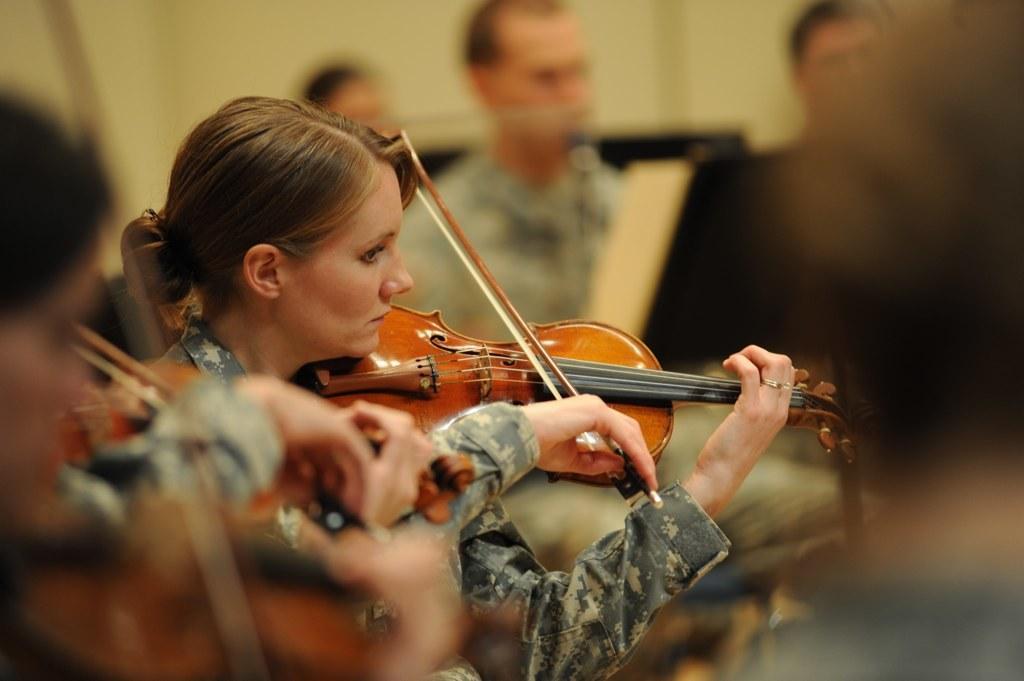Please provide a concise description of this image. This picture is blur, in this picture there are people, among them few people playing musical instruments. In the background of the image we can see wall. 